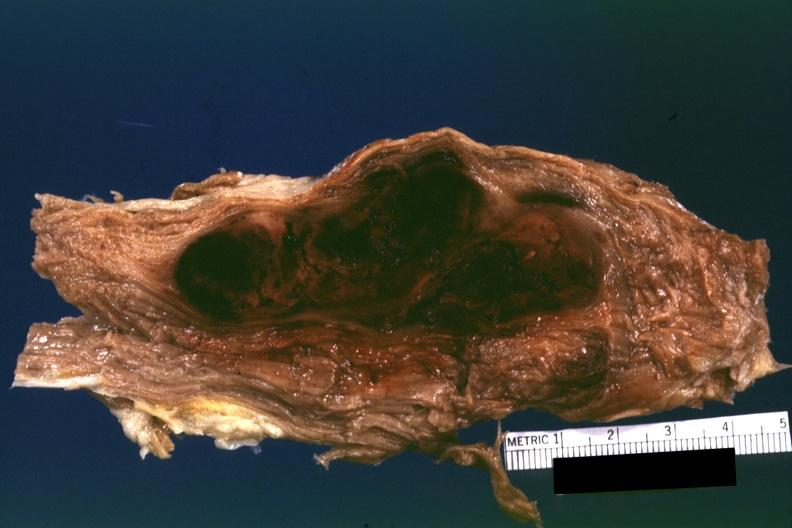what appears to be in a psoas muscle if so the diagnosis on all other slides of this case in this file needs to be changed?
Answer the question using a single word or phrase. This 